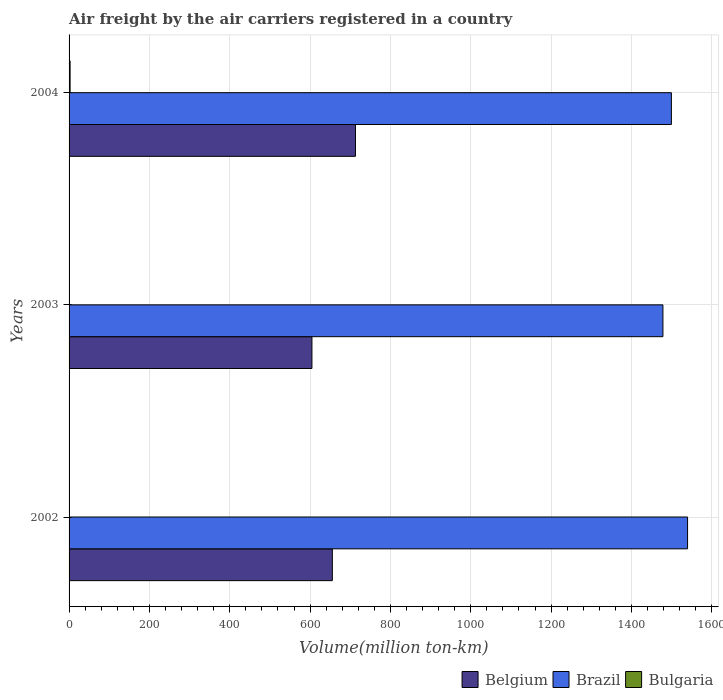How many different coloured bars are there?
Provide a succinct answer. 3. How many groups of bars are there?
Give a very brief answer. 3. What is the label of the 1st group of bars from the top?
Offer a very short reply. 2004. In how many cases, is the number of bars for a given year not equal to the number of legend labels?
Your answer should be very brief. 0. What is the volume of the air carriers in Brazil in 2004?
Offer a terse response. 1499.48. Across all years, what is the maximum volume of the air carriers in Bulgaria?
Give a very brief answer. 2.56. Across all years, what is the minimum volume of the air carriers in Belgium?
Ensure brevity in your answer.  604.61. In which year was the volume of the air carriers in Bulgaria maximum?
Give a very brief answer. 2004. What is the total volume of the air carriers in Brazil in the graph?
Your response must be concise. 4517.59. What is the difference between the volume of the air carriers in Bulgaria in 2002 and that in 2004?
Offer a very short reply. -2.53. What is the difference between the volume of the air carriers in Brazil in 2004 and the volume of the air carriers in Belgium in 2003?
Offer a terse response. 894.88. What is the average volume of the air carriers in Belgium per year?
Offer a terse response. 657.66. In the year 2003, what is the difference between the volume of the air carriers in Belgium and volume of the air carriers in Bulgaria?
Offer a terse response. 603.98. In how many years, is the volume of the air carriers in Brazil greater than 240 million ton-km?
Your response must be concise. 3. What is the ratio of the volume of the air carriers in Bulgaria in 2002 to that in 2003?
Your response must be concise. 0.05. Is the volume of the air carriers in Brazil in 2003 less than that in 2004?
Provide a short and direct response. Yes. What is the difference between the highest and the second highest volume of the air carriers in Belgium?
Your response must be concise. 57.53. What is the difference between the highest and the lowest volume of the air carriers in Belgium?
Make the answer very short. 108.34. What does the 2nd bar from the top in 2002 represents?
Make the answer very short. Brazil. What does the 2nd bar from the bottom in 2003 represents?
Your answer should be very brief. Brazil. Is it the case that in every year, the sum of the volume of the air carriers in Brazil and volume of the air carriers in Belgium is greater than the volume of the air carriers in Bulgaria?
Your response must be concise. Yes. How many bars are there?
Offer a terse response. 9. Are all the bars in the graph horizontal?
Keep it short and to the point. Yes. How many years are there in the graph?
Your response must be concise. 3. Are the values on the major ticks of X-axis written in scientific E-notation?
Offer a very short reply. No. Does the graph contain any zero values?
Provide a succinct answer. No. How many legend labels are there?
Ensure brevity in your answer.  3. What is the title of the graph?
Your answer should be compact. Air freight by the air carriers registered in a country. Does "Zambia" appear as one of the legend labels in the graph?
Offer a very short reply. No. What is the label or title of the X-axis?
Offer a very short reply. Volume(million ton-km). What is the Volume(million ton-km) of Belgium in 2002?
Give a very brief answer. 655.42. What is the Volume(million ton-km) in Brazil in 2002?
Ensure brevity in your answer.  1539.74. What is the Volume(million ton-km) in Bulgaria in 2002?
Your answer should be very brief. 0.03. What is the Volume(million ton-km) of Belgium in 2003?
Give a very brief answer. 604.61. What is the Volume(million ton-km) of Brazil in 2003?
Keep it short and to the point. 1478.37. What is the Volume(million ton-km) in Bulgaria in 2003?
Provide a succinct answer. 0.63. What is the Volume(million ton-km) in Belgium in 2004?
Ensure brevity in your answer.  712.95. What is the Volume(million ton-km) of Brazil in 2004?
Give a very brief answer. 1499.48. What is the Volume(million ton-km) in Bulgaria in 2004?
Your answer should be very brief. 2.56. Across all years, what is the maximum Volume(million ton-km) of Belgium?
Your answer should be compact. 712.95. Across all years, what is the maximum Volume(million ton-km) in Brazil?
Your answer should be compact. 1539.74. Across all years, what is the maximum Volume(million ton-km) in Bulgaria?
Provide a succinct answer. 2.56. Across all years, what is the minimum Volume(million ton-km) in Belgium?
Offer a terse response. 604.61. Across all years, what is the minimum Volume(million ton-km) in Brazil?
Ensure brevity in your answer.  1478.37. Across all years, what is the minimum Volume(million ton-km) in Bulgaria?
Offer a terse response. 0.03. What is the total Volume(million ton-km) of Belgium in the graph?
Offer a terse response. 1972.98. What is the total Volume(million ton-km) in Brazil in the graph?
Your answer should be very brief. 4517.59. What is the total Volume(million ton-km) in Bulgaria in the graph?
Your answer should be compact. 3.22. What is the difference between the Volume(million ton-km) in Belgium in 2002 and that in 2003?
Make the answer very short. 50.82. What is the difference between the Volume(million ton-km) in Brazil in 2002 and that in 2003?
Your answer should be compact. 61.37. What is the difference between the Volume(million ton-km) of Bulgaria in 2002 and that in 2003?
Your answer should be compact. -0.6. What is the difference between the Volume(million ton-km) in Belgium in 2002 and that in 2004?
Make the answer very short. -57.53. What is the difference between the Volume(million ton-km) of Brazil in 2002 and that in 2004?
Provide a succinct answer. 40.25. What is the difference between the Volume(million ton-km) of Bulgaria in 2002 and that in 2004?
Offer a very short reply. -2.53. What is the difference between the Volume(million ton-km) in Belgium in 2003 and that in 2004?
Your answer should be compact. -108.34. What is the difference between the Volume(million ton-km) of Brazil in 2003 and that in 2004?
Ensure brevity in your answer.  -21.11. What is the difference between the Volume(million ton-km) of Bulgaria in 2003 and that in 2004?
Ensure brevity in your answer.  -1.93. What is the difference between the Volume(million ton-km) in Belgium in 2002 and the Volume(million ton-km) in Brazil in 2003?
Make the answer very short. -822.95. What is the difference between the Volume(million ton-km) of Belgium in 2002 and the Volume(million ton-km) of Bulgaria in 2003?
Provide a short and direct response. 654.8. What is the difference between the Volume(million ton-km) in Brazil in 2002 and the Volume(million ton-km) in Bulgaria in 2003?
Your response must be concise. 1539.11. What is the difference between the Volume(million ton-km) in Belgium in 2002 and the Volume(million ton-km) in Brazil in 2004?
Keep it short and to the point. -844.06. What is the difference between the Volume(million ton-km) of Belgium in 2002 and the Volume(million ton-km) of Bulgaria in 2004?
Provide a short and direct response. 652.87. What is the difference between the Volume(million ton-km) of Brazil in 2002 and the Volume(million ton-km) of Bulgaria in 2004?
Keep it short and to the point. 1537.18. What is the difference between the Volume(million ton-km) of Belgium in 2003 and the Volume(million ton-km) of Brazil in 2004?
Your answer should be compact. -894.88. What is the difference between the Volume(million ton-km) in Belgium in 2003 and the Volume(million ton-km) in Bulgaria in 2004?
Keep it short and to the point. 602.05. What is the difference between the Volume(million ton-km) in Brazil in 2003 and the Volume(million ton-km) in Bulgaria in 2004?
Your response must be concise. 1475.81. What is the average Volume(million ton-km) of Belgium per year?
Offer a very short reply. 657.66. What is the average Volume(million ton-km) in Brazil per year?
Your answer should be very brief. 1505.86. What is the average Volume(million ton-km) in Bulgaria per year?
Offer a very short reply. 1.07. In the year 2002, what is the difference between the Volume(million ton-km) in Belgium and Volume(million ton-km) in Brazil?
Provide a succinct answer. -884.31. In the year 2002, what is the difference between the Volume(million ton-km) in Belgium and Volume(million ton-km) in Bulgaria?
Offer a very short reply. 655.39. In the year 2002, what is the difference between the Volume(million ton-km) in Brazil and Volume(million ton-km) in Bulgaria?
Provide a short and direct response. 1539.71. In the year 2003, what is the difference between the Volume(million ton-km) in Belgium and Volume(million ton-km) in Brazil?
Provide a short and direct response. -873.76. In the year 2003, what is the difference between the Volume(million ton-km) in Belgium and Volume(million ton-km) in Bulgaria?
Keep it short and to the point. 603.98. In the year 2003, what is the difference between the Volume(million ton-km) in Brazil and Volume(million ton-km) in Bulgaria?
Keep it short and to the point. 1477.74. In the year 2004, what is the difference between the Volume(million ton-km) in Belgium and Volume(million ton-km) in Brazil?
Give a very brief answer. -786.53. In the year 2004, what is the difference between the Volume(million ton-km) in Belgium and Volume(million ton-km) in Bulgaria?
Your answer should be compact. 710.39. In the year 2004, what is the difference between the Volume(million ton-km) of Brazil and Volume(million ton-km) of Bulgaria?
Give a very brief answer. 1496.93. What is the ratio of the Volume(million ton-km) in Belgium in 2002 to that in 2003?
Your answer should be compact. 1.08. What is the ratio of the Volume(million ton-km) of Brazil in 2002 to that in 2003?
Keep it short and to the point. 1.04. What is the ratio of the Volume(million ton-km) in Bulgaria in 2002 to that in 2003?
Ensure brevity in your answer.  0.05. What is the ratio of the Volume(million ton-km) in Belgium in 2002 to that in 2004?
Give a very brief answer. 0.92. What is the ratio of the Volume(million ton-km) of Brazil in 2002 to that in 2004?
Your answer should be very brief. 1.03. What is the ratio of the Volume(million ton-km) in Bulgaria in 2002 to that in 2004?
Provide a short and direct response. 0.01. What is the ratio of the Volume(million ton-km) of Belgium in 2003 to that in 2004?
Keep it short and to the point. 0.85. What is the ratio of the Volume(million ton-km) in Brazil in 2003 to that in 2004?
Your response must be concise. 0.99. What is the ratio of the Volume(million ton-km) in Bulgaria in 2003 to that in 2004?
Provide a short and direct response. 0.25. What is the difference between the highest and the second highest Volume(million ton-km) in Belgium?
Keep it short and to the point. 57.53. What is the difference between the highest and the second highest Volume(million ton-km) of Brazil?
Make the answer very short. 40.25. What is the difference between the highest and the second highest Volume(million ton-km) in Bulgaria?
Provide a short and direct response. 1.93. What is the difference between the highest and the lowest Volume(million ton-km) in Belgium?
Your response must be concise. 108.34. What is the difference between the highest and the lowest Volume(million ton-km) of Brazil?
Provide a short and direct response. 61.37. What is the difference between the highest and the lowest Volume(million ton-km) in Bulgaria?
Ensure brevity in your answer.  2.53. 